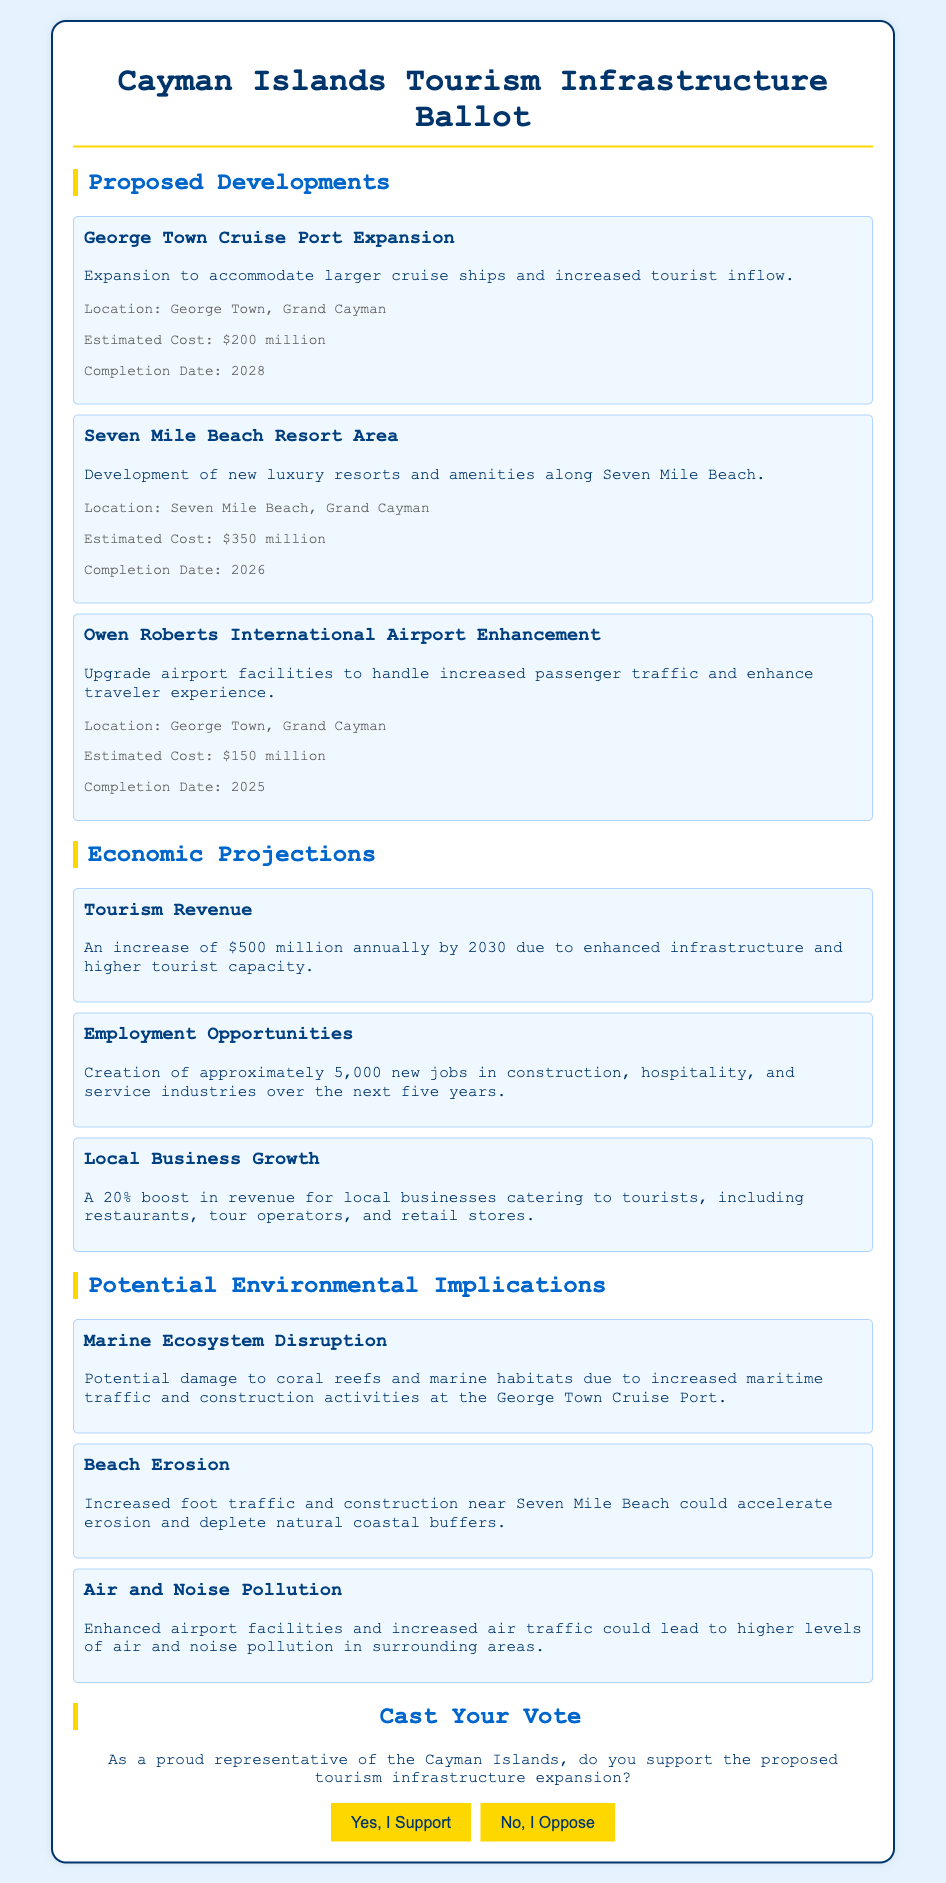what is the estimated cost of the George Town Cruise Port Expansion? The estimated cost for the George Town Cruise Port Expansion is mentioned specifically in the document as $200 million.
Answer: $200 million what is the completion date for the Seven Mile Beach Resort Area? The document states that the Seven Mile Beach Resort Area is expected to be completed in 2026.
Answer: 2026 how many new jobs are projected to be created? The document indicates that approximately 5,000 new jobs will be created in various industries over the next five years.
Answer: 5,000 which environmental implication mentions coral reefs? The potential environmental implication discussing coral reefs is titled "Marine Ecosystem Disruption."
Answer: Marine Ecosystem Disruption what is the predicted annual increase in tourism revenue by 2030? The document specifies an increase of $500 million annually by 2030 due to enhanced infrastructure and higher tourist capacity.
Answer: $500 million how much is the estimated cost for Owen Roberts International Airport Enhancement? The estimated cost for enhancing Owen Roberts International Airport is stated as $150 million in the document.
Answer: $150 million what type of infrastructure is included in the proposed developments? The proposed developments include a cruise port expansion, luxury resort area, and airport enhancement.
Answer: cruise port expansion, luxury resort area, airport enhancement who would largely benefit from the economic growth? Local businesses, including restaurants, tour operators, and retail stores, would largely benefit from the economic growth as indicated by the projected boost in revenue.
Answer: local businesses what type of document is this? This document is a ballot designed to gather community opinions on expanding tourism infrastructure.
Answer: ballot 